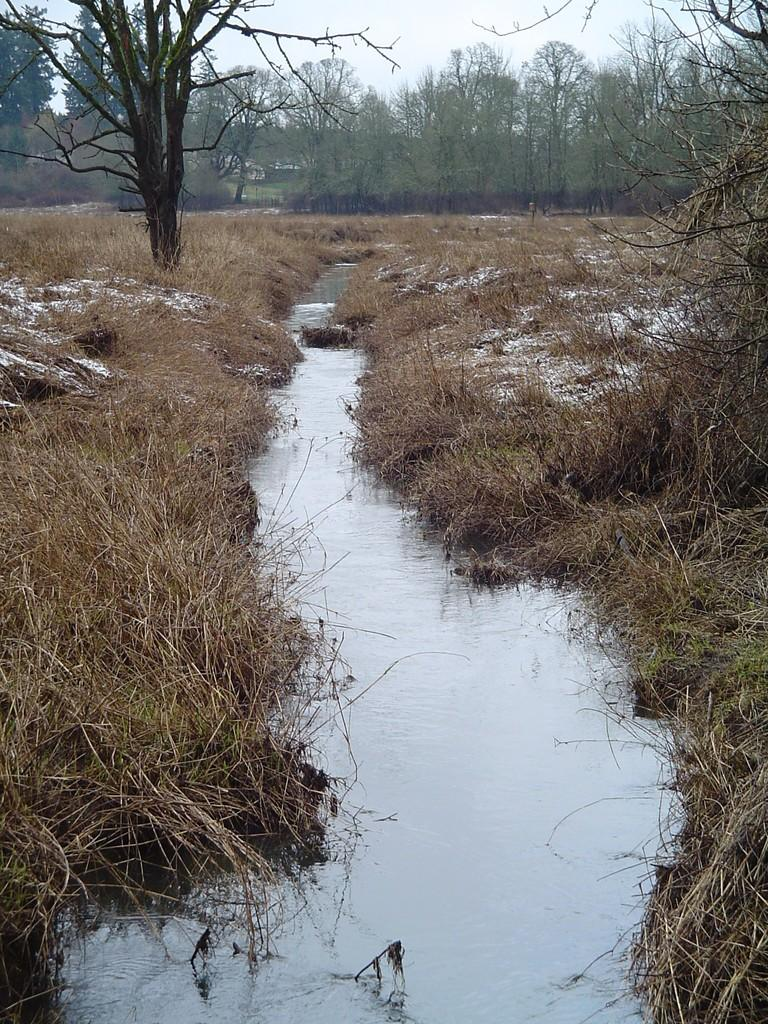What is the main subject of the image? The main subject of the image is a water flow. Where is the water flow located in relation to the grass? The water flow is between grass in the image. What type of vegetation is visible in the image? There are trees visible in the image. Can you tell me how many tomatoes are growing on the trees in the image? There are no tomatoes present in the image, as the trees are not mentioned as bearing fruit. What type of experience can be gained from observing the water flow in the image? The image does not convey any specific experience; it simply depicts a water flow between grass. --- 